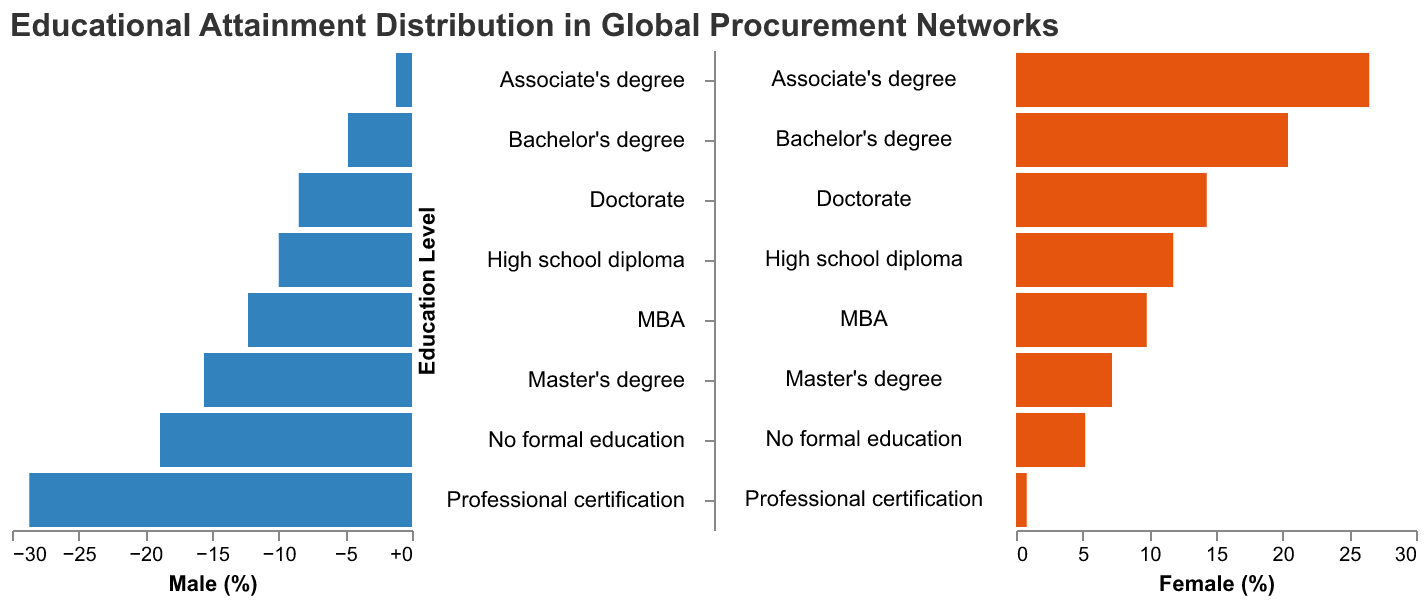What is the title of the figure? The title is displayed at the top of the figure. It reads, "Educational Attainment Distribution in Global Procurement Networks".
Answer: Educational Attainment Distribution in Global Procurement Networks Which gender has a higher percentage at the Master's degree level? By comparing the bar lengths at the Master's degree level, the bar for females is longer than the bar for males. The percentages are 18.9% for males and 20.4% for females.
Answer: Female How many different educational levels are represented in the figure? The y-axis lists each educational level. Counting them, there are eight different educational levels represented.
Answer: Eight What is the percentage of males with a Bachelor’s degree? By looking at the bar corresponding to the Bachelor’s degree on the left side of the figure, the percentage is marked as 28.7%.
Answer: 28.7% Which gender has a higher percentage for no formal education? By comparing the bar lengths at the "No formal education" level, the bar for males is longer. The percentages are 1.2% for males and 0.8% for females.
Answer: Male What is the total percentage of male employees with a Master's degree and MBA combined? Sum the percentages for males with a Master's degree (18.9%) and an MBA (15.6%): 18.9 + 15.6 = 34.5%.
Answer: 34.5% Which educational level has the highest percentage of employees for both genders combined? Add the percentages of males and females for each educational level and identify the highest total:
- No formal education: 1.2 + 0.8 = 2.0
- High school diploma: 8.5 + 7.2 = 15.7
- Associate’s degree: 12.3 + 11.8 = 24.1
- Bachelor’s degree: 28.7 + 26.5 = 55.2
- Master’s degree: 18.9 + 20.4 = 39.3
- MBA: 15.6 + 14.3 = 29.9
- Doctorate: 4.8 + 5.2 = 10.0
- Professional certification: 10.0 + 9.8 = 19.8
The highest combined percentage is for Bachelor's degree, with a total of 55.2%.
Answer: Bachelor's degree Are there more females or males with professional certification? By comparing the bar lengths at the "Professional certification" level, the percentage for females is slightly lower than for males. The percentages are 9.8% for females and 10.0% for males.
Answer: Males 